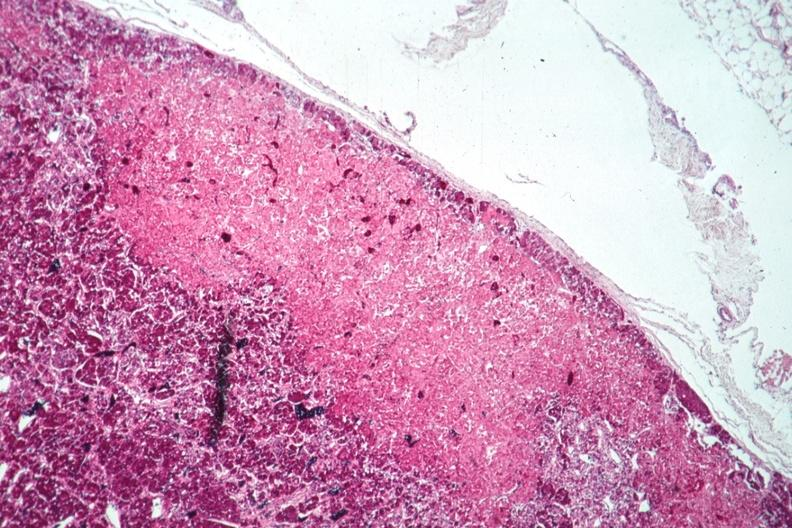what is present?
Answer the question using a single word or phrase. Pituitary 